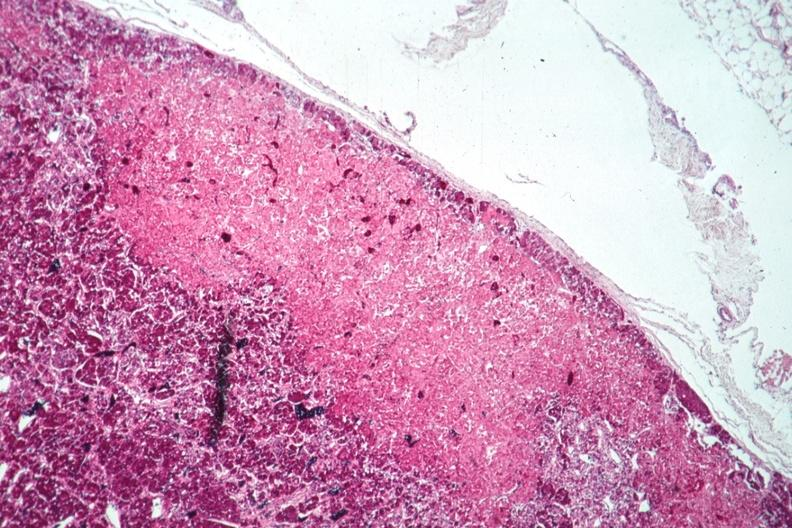what is present?
Answer the question using a single word or phrase. Pituitary 